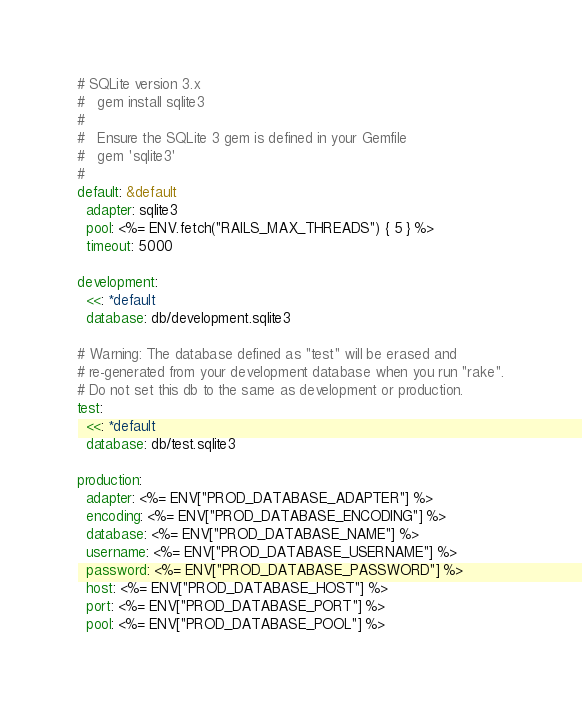<code> <loc_0><loc_0><loc_500><loc_500><_YAML_># SQLite version 3.x
#   gem install sqlite3
#
#   Ensure the SQLite 3 gem is defined in your Gemfile
#   gem 'sqlite3'
#
default: &default
  adapter: sqlite3
  pool: <%= ENV.fetch("RAILS_MAX_THREADS") { 5 } %>
  timeout: 5000

development:
  <<: *default
  database: db/development.sqlite3

# Warning: The database defined as "test" will be erased and
# re-generated from your development database when you run "rake".
# Do not set this db to the same as development or production.
test:
  <<: *default
  database: db/test.sqlite3

production:
  adapter: <%= ENV["PROD_DATABASE_ADAPTER"] %>
  encoding: <%= ENV["PROD_DATABASE_ENCODING"] %>
  database: <%= ENV["PROD_DATABASE_NAME"] %>
  username: <%= ENV["PROD_DATABASE_USERNAME"] %>
  password: <%= ENV["PROD_DATABASE_PASSWORD"] %>
  host: <%= ENV["PROD_DATABASE_HOST"] %>
  port: <%= ENV["PROD_DATABASE_PORT"] %>
  pool: <%= ENV["PROD_DATABASE_POOL"] %>
</code> 